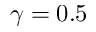Convert formula to latex. <formula><loc_0><loc_0><loc_500><loc_500>\gamma = 0 . 5</formula> 